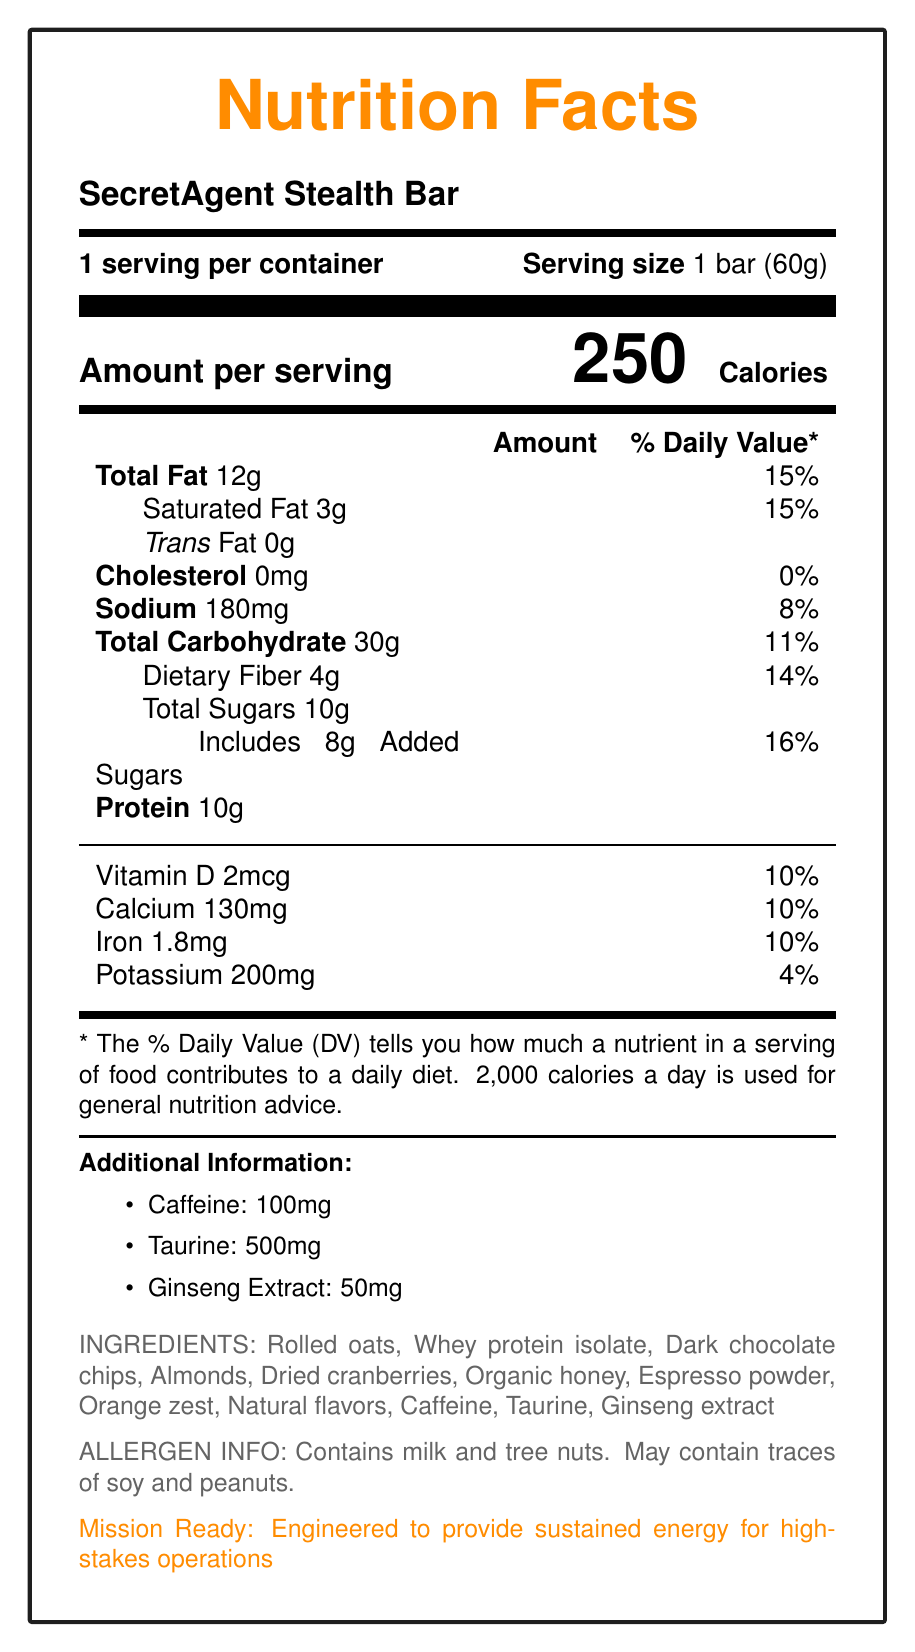what is the serving size of the SecretAgent Stealth Bar? The serving size is explicitly mentioned as "1 bar (60g)" in the document.
Answer: 1 bar (60g) how many calories are there per serving? The document shows that the energy bar contains 250 calories per serving.
Answer: 250 what are the dimensions of the bar? The dimensions mentioned in the document are 4 inches x 1.5 inches x 0.75 inches.
Answer: 4 inches x 1.5 inches x 0.75 inches how much dietary fiber does the energy bar have? The document specifies that the energy bar contains 4g of dietary fiber.
Answer: 4g what is the percentage daily value of saturated fat in the bar? The percentage daily value for saturated fat is provided as 15%.
Answer: 15% what additional features does the wrapper of the SecretAgent Stealth Bar have? In the document, it mentions that the wrapper material is high-tensile strength polymer.
Answer: High-tensile strength polymer how much caffeine is present in the bar? A. 50mg B. 100mg C. 150mg D. 200mg The document lists the amount of caffeine as 100mg.
Answer: B what is the main flavor profile of the SecretAgent Stealth Bar? A. Vanilla Almond B. Dark Chocolate Espresso with Orange Zest C. Raspberry Lemon D. Peanut Butter The provided flavor profile is "Dark chocolate espresso with a hint of orange zest."
Answer: B does the SecretAgent Stealth Bar contain tree nuts? The allergen information states that the bar contains milk and tree nuts.
Answer: Yes summarize the overall document. The explanation includes an organized summary covering all the main points mentioned in the document.
Answer: The document provides detailed nutrition facts and additional features of the SecretAgent Stealth Bar. It includes information about serving size, calories, total fat, cholesterol, sodium, carbohydrates, and protein. It also lists ingredients, allergen information, storage instructions, and additional nutritional elements like caffeine, taurine, and ginseng extract. Furthermore, the document describes the spy-oriented features of the bar, such as a hidden compartment with a miniature lockpick set, along with the flavor profile and manufacturer details. how much protein is in the bar? The document clearly states that the bar contains 10g of protein per serving.
Answer: 10g what is the hidden compartment of the energy bar designed to store? The document reveals that the hidden compartment of the energy bar contains a miniature lockpick set.
Answer: Miniature lockpick set is there any cholesterol in the SecretAgent Stealth Bar? Yes/No The document specifies that the cholesterol content is 0mg, equating to 0%.
Answer: No who is the manufacturer of the SecretAgent Stealth Bar? The manufacturer is listed as Covert Nutrition Labs in the document.
Answer: Covert Nutrition Labs what is the expiration date of the SecretAgent Stealth Bar? The expiration date is 18 months from the date of manufacture as given in the document.
Answer: 18 months from date of manufacture what is the barcode of the SecretAgent Stealth Bar? The document lists the barcode number as 7891234567890.
Answer: 7891234567890 what is the sodium content in the SecretAgent Stealth Bar? The document indicates that there is 180mg of sodium in the bar.
Answer: 180mg how many servings are there per container? The document specifies that there is 1 serving per container.
Answer: 1 what company distributes the SecretAgent Stealth Bar? The document mentions the distributor as Global Espionage Supplies Inc.
Answer: Global Espionage Supplies Inc. how can you store the SecretAgent Stealth Bar? The document provides storage instructions to store the bar in a cool, dry place and avoid extreme temperatures or moisture.
Answer: Store in a cool, dry place. Do not expose to extreme temperatures or moisture. what is the amount of taurine in the SecretAgent Stealth Bar? The document states that the bar contains 500mg of taurine.
Answer: 500mg how much iron does the bar contain? The document shows that there is 1.8mg of iron in the bar.
Answer: 1.8mg does the document specify how much Vitamin C is in the bar? The document does not provide any details regarding the Vitamin C content in the bar.
Answer: Not enough information 